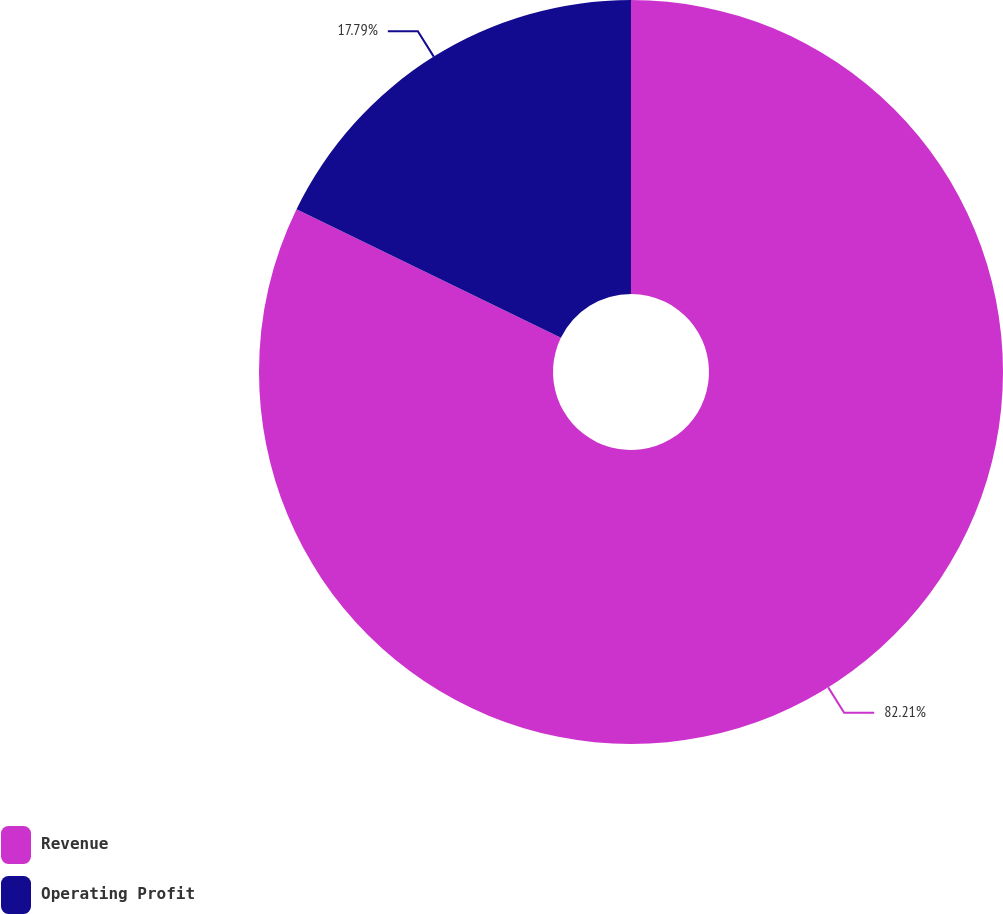Convert chart to OTSL. <chart><loc_0><loc_0><loc_500><loc_500><pie_chart><fcel>Revenue<fcel>Operating Profit<nl><fcel>82.21%<fcel>17.79%<nl></chart> 